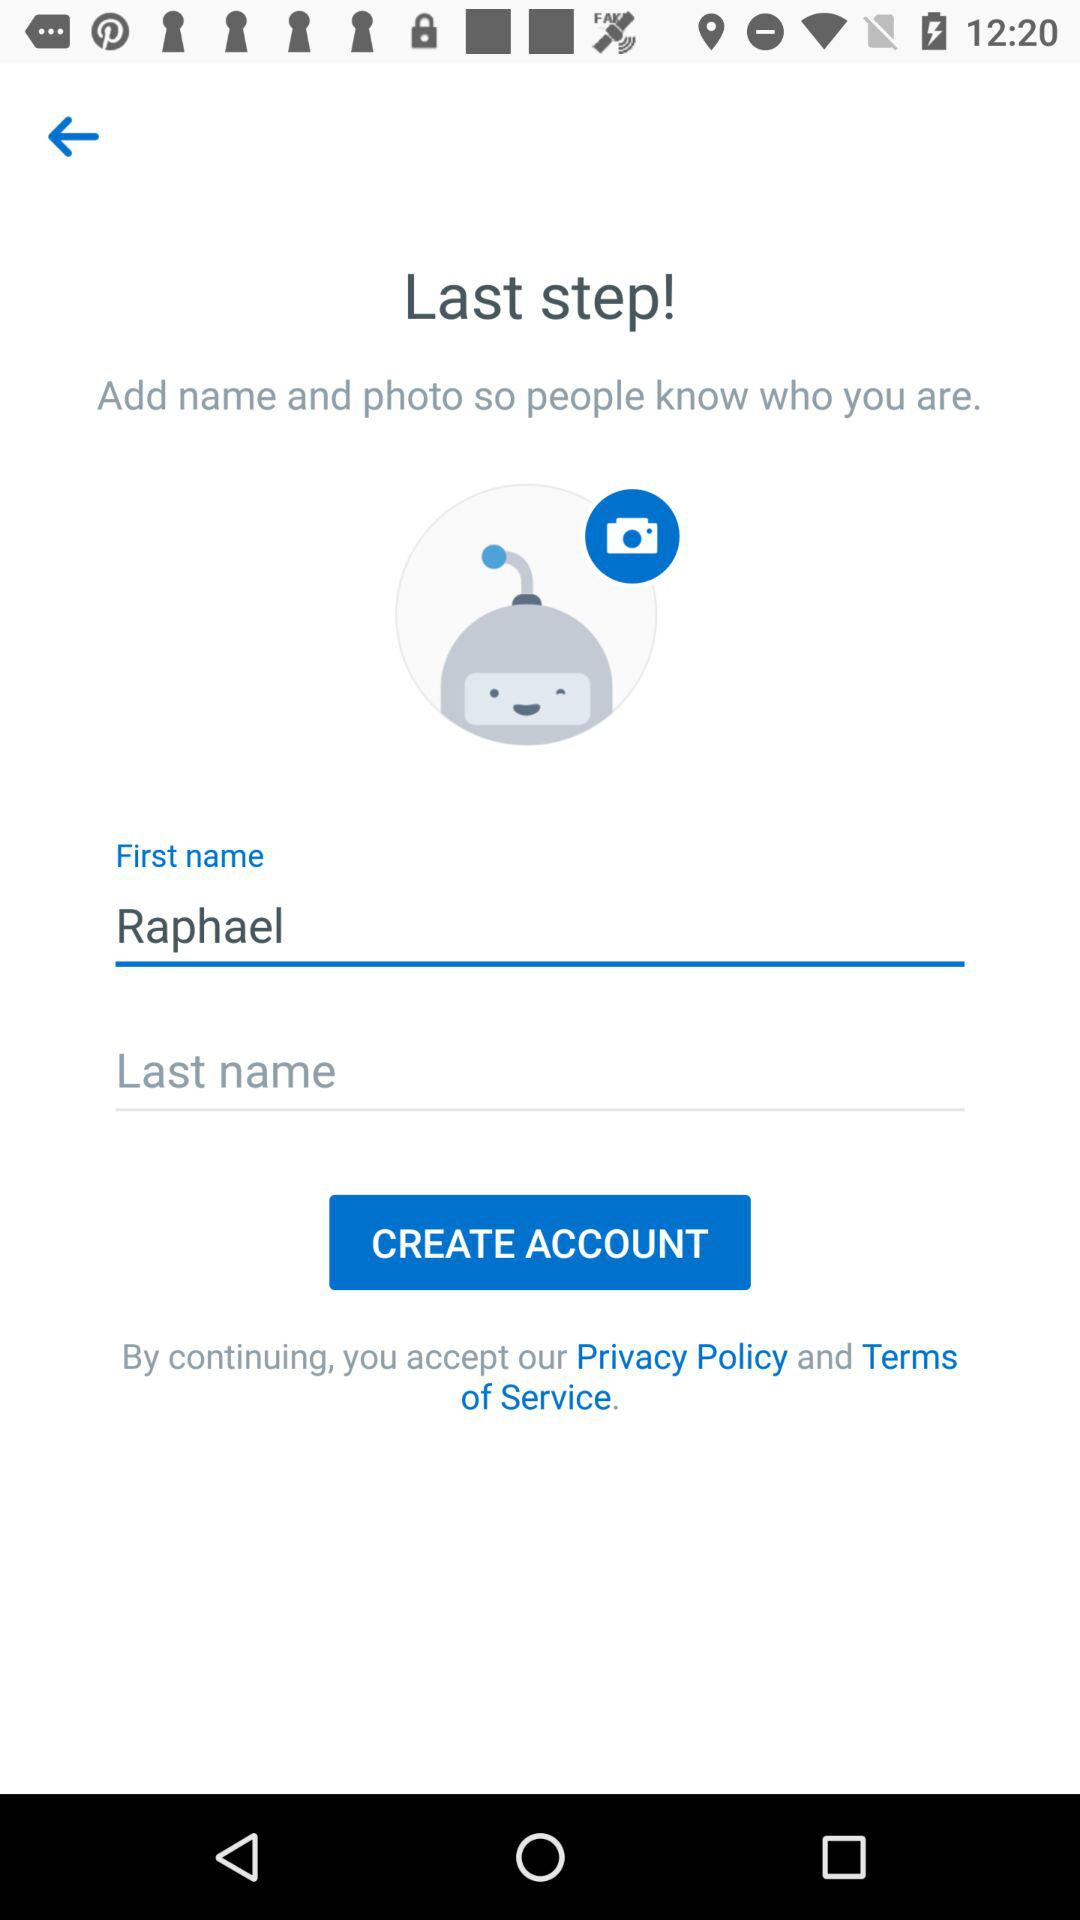How many text inputs are required to create an account?
Answer the question using a single word or phrase. 2 